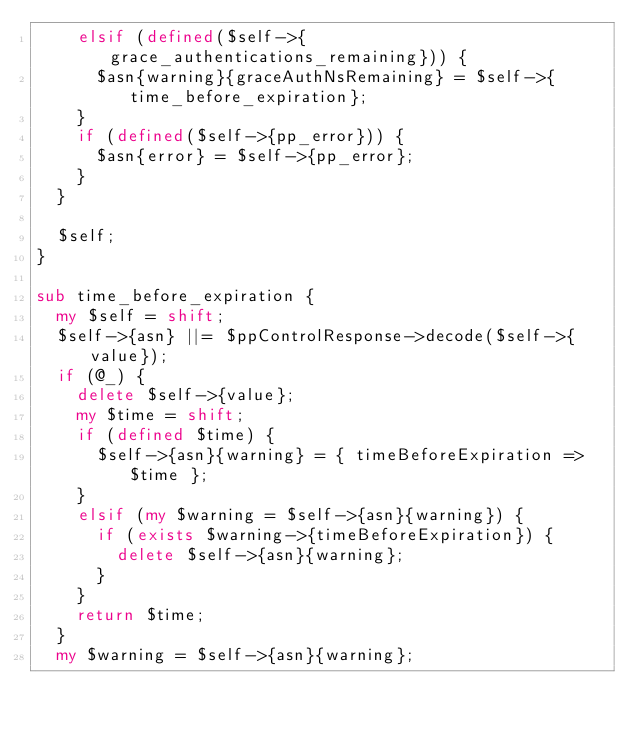Convert code to text. <code><loc_0><loc_0><loc_500><loc_500><_Perl_>    elsif (defined($self->{grace_authentications_remaining})) {
      $asn{warning}{graceAuthNsRemaining} = $self->{time_before_expiration};
    }
    if (defined($self->{pp_error})) {
      $asn{error} = $self->{pp_error};
    }
  }

  $self;
}

sub time_before_expiration {
  my $self = shift;
  $self->{asn} ||= $ppControlResponse->decode($self->{value});
  if (@_) {
    delete $self->{value};
    my $time = shift;
    if (defined $time) {
      $self->{asn}{warning} = { timeBeforeExpiration => $time };
    }
    elsif (my $warning = $self->{asn}{warning}) {
      if (exists $warning->{timeBeforeExpiration}) {
        delete $self->{asn}{warning};
      }
    }
    return $time;
  }
  my $warning = $self->{asn}{warning};</code> 